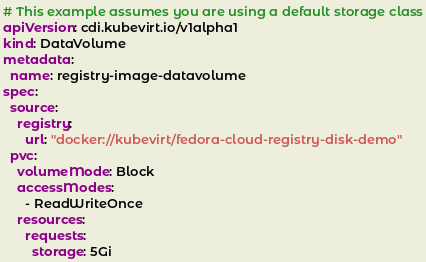Convert code to text. <code><loc_0><loc_0><loc_500><loc_500><_YAML_># This example assumes you are using a default storage class
apiVersion: cdi.kubevirt.io/v1alpha1
kind: DataVolume
metadata:
  name: registry-image-datavolume
spec:
  source:
    registry:
      url: "docker://kubevirt/fedora-cloud-registry-disk-demo"
  pvc:
    volumeMode: Block
    accessModes:
      - ReadWriteOnce
    resources:
      requests:
        storage: 5Gi
</code> 